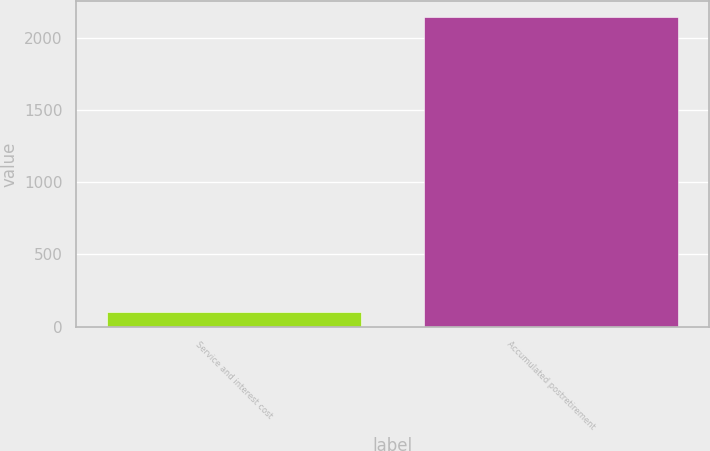<chart> <loc_0><loc_0><loc_500><loc_500><bar_chart><fcel>Service and interest cost<fcel>Accumulated postretirement<nl><fcel>100<fcel>2147<nl></chart> 